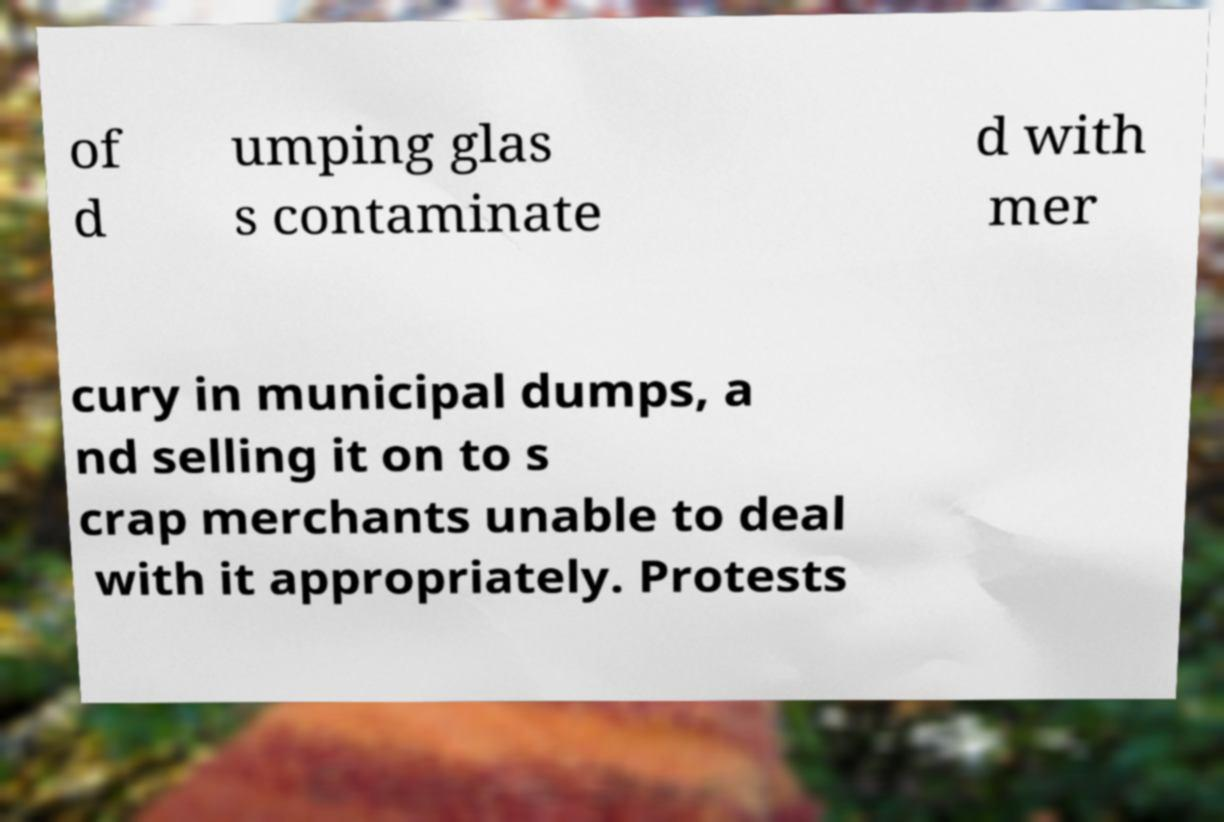Please read and relay the text visible in this image. What does it say? of d umping glas s contaminate d with mer cury in municipal dumps, a nd selling it on to s crap merchants unable to deal with it appropriately. Protests 